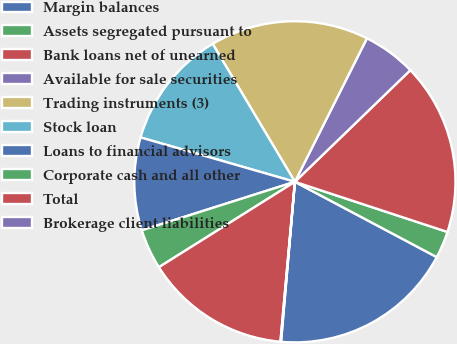Convert chart to OTSL. <chart><loc_0><loc_0><loc_500><loc_500><pie_chart><fcel>Margin balances<fcel>Assets segregated pursuant to<fcel>Bank loans net of unearned<fcel>Available for sale securities<fcel>Trading instruments (3)<fcel>Stock loan<fcel>Loans to financial advisors<fcel>Corporate cash and all other<fcel>Total<fcel>Brokerage client liabilities<nl><fcel>18.61%<fcel>2.71%<fcel>17.29%<fcel>5.36%<fcel>15.96%<fcel>11.99%<fcel>9.34%<fcel>4.04%<fcel>14.64%<fcel>0.06%<nl></chart> 